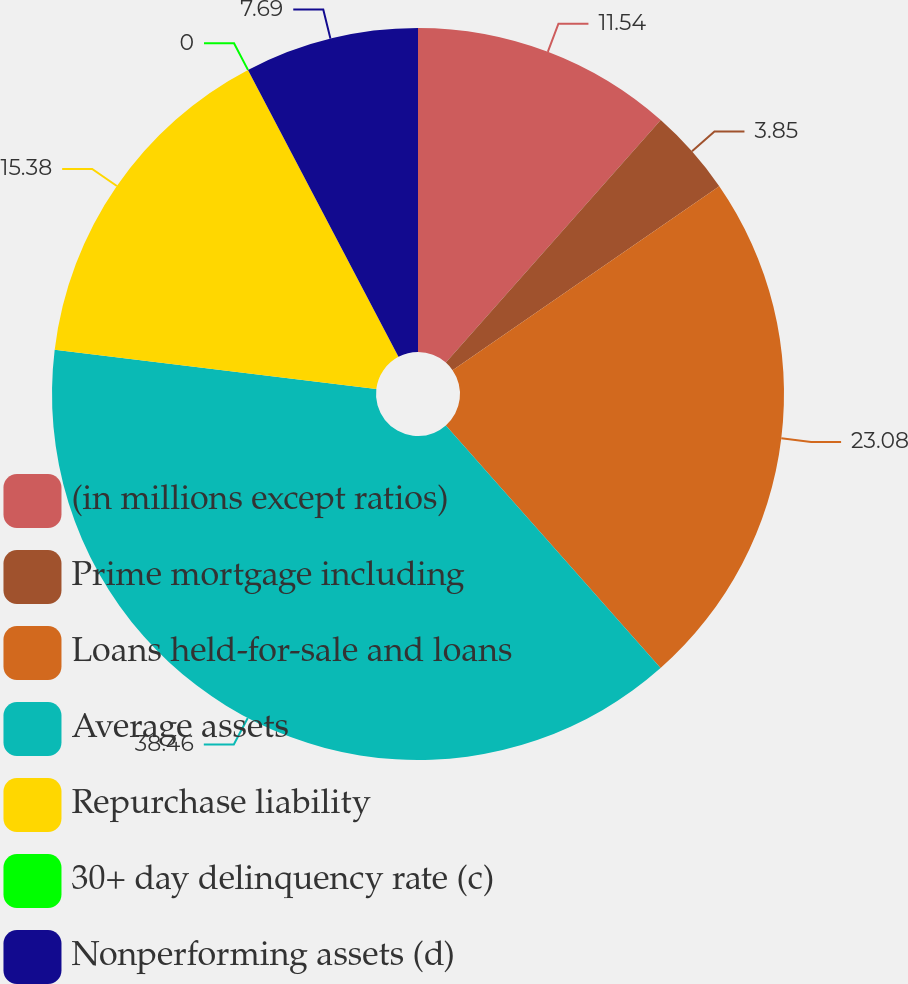Convert chart to OTSL. <chart><loc_0><loc_0><loc_500><loc_500><pie_chart><fcel>(in millions except ratios)<fcel>Prime mortgage including<fcel>Loans held-for-sale and loans<fcel>Average assets<fcel>Repurchase liability<fcel>30+ day delinquency rate (c)<fcel>Nonperforming assets (d)<nl><fcel>11.54%<fcel>3.85%<fcel>23.08%<fcel>38.46%<fcel>15.38%<fcel>0.0%<fcel>7.69%<nl></chart> 